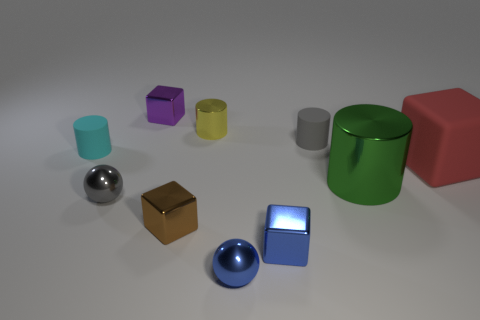What is the size of the metal ball that is behind the metal ball that is in front of the tiny shiny thing left of the tiny purple metallic object? The metal ball positioned behind the foremost metal ball near the small reflective object to the left of the miniature purple metallic cube appears to be medium in size compared to the other objects in the image. 